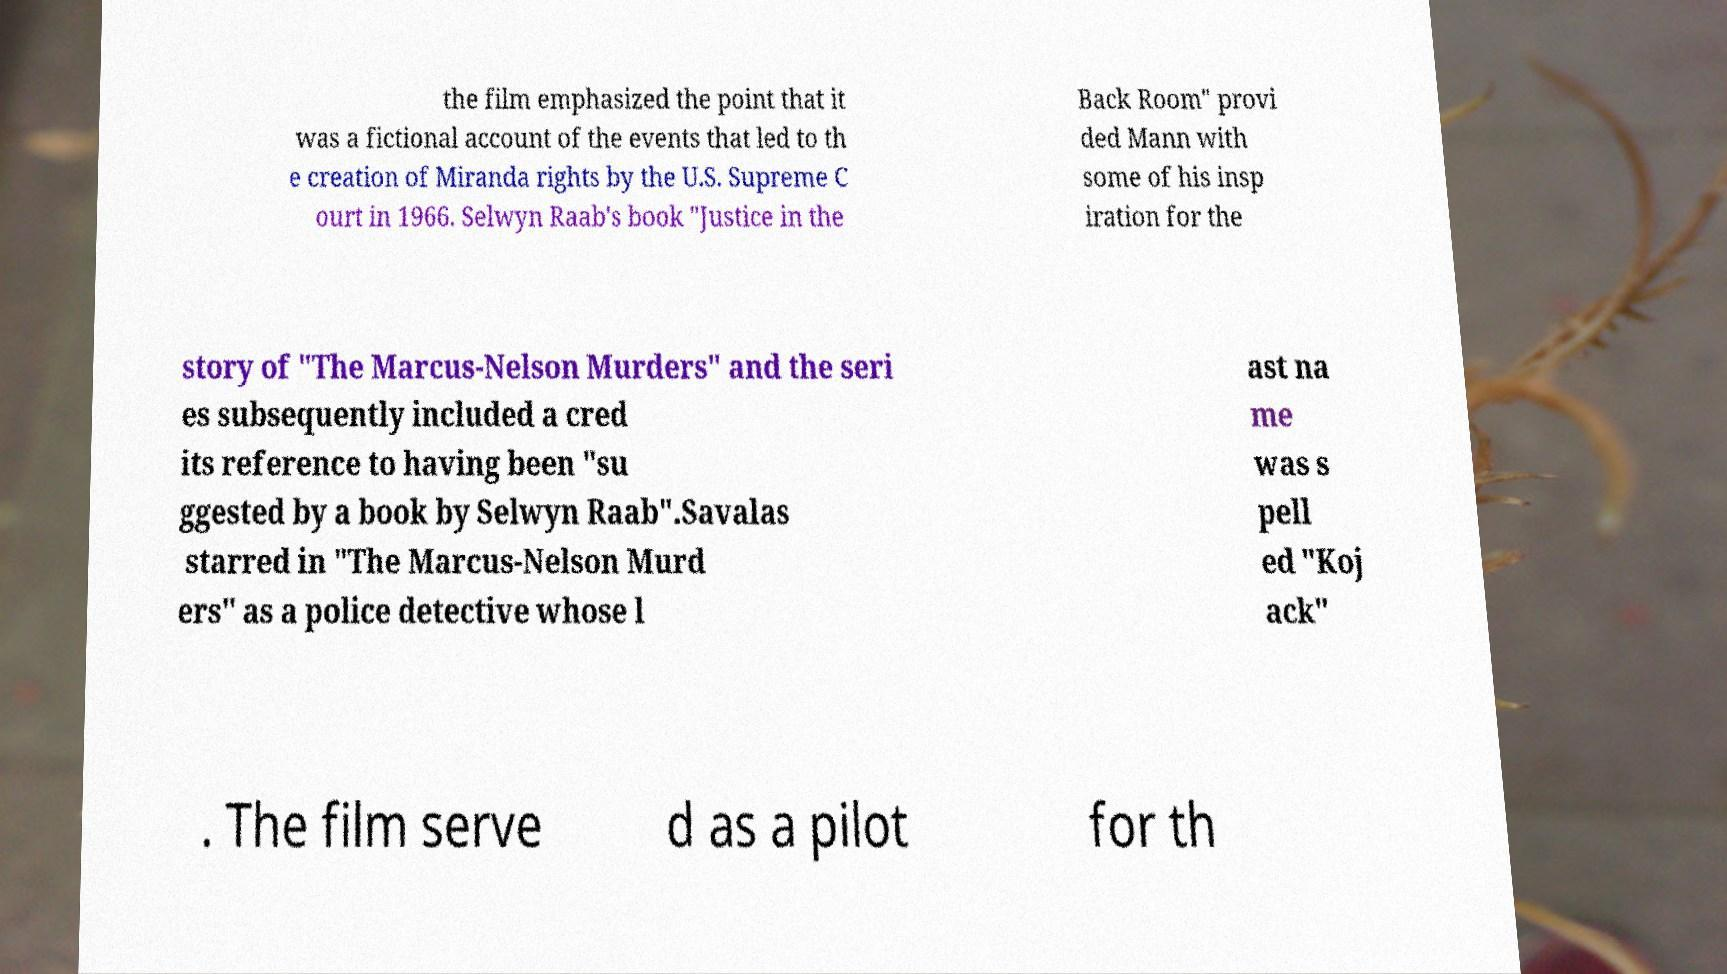What messages or text are displayed in this image? I need them in a readable, typed format. the film emphasized the point that it was a fictional account of the events that led to th e creation of Miranda rights by the U.S. Supreme C ourt in 1966. Selwyn Raab's book "Justice in the Back Room" provi ded Mann with some of his insp iration for the story of "The Marcus-Nelson Murders" and the seri es subsequently included a cred its reference to having been "su ggested by a book by Selwyn Raab".Savalas starred in "The Marcus-Nelson Murd ers" as a police detective whose l ast na me was s pell ed "Koj ack" . The film serve d as a pilot for th 